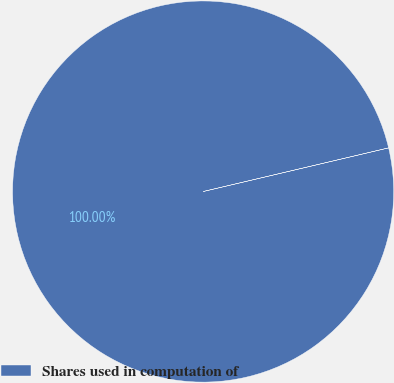Convert chart. <chart><loc_0><loc_0><loc_500><loc_500><pie_chart><fcel>Shares used in computation of<nl><fcel>100.0%<nl></chart> 